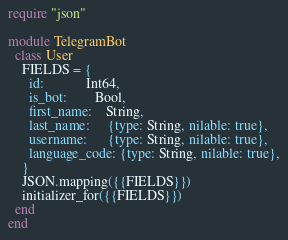<code> <loc_0><loc_0><loc_500><loc_500><_Crystal_>require "json"

module TelegramBot
  class User
    FIELDS = {
      id:            Int64,
      is_bot:        Bool,
      first_name:    String,
      last_name:     {type: String, nilable: true},
      username:      {type: String, nilable: true},
      language_code: {type: String, nilable: true},
    }
    JSON.mapping({{FIELDS}})
    initializer_for({{FIELDS}})
  end
end
</code> 